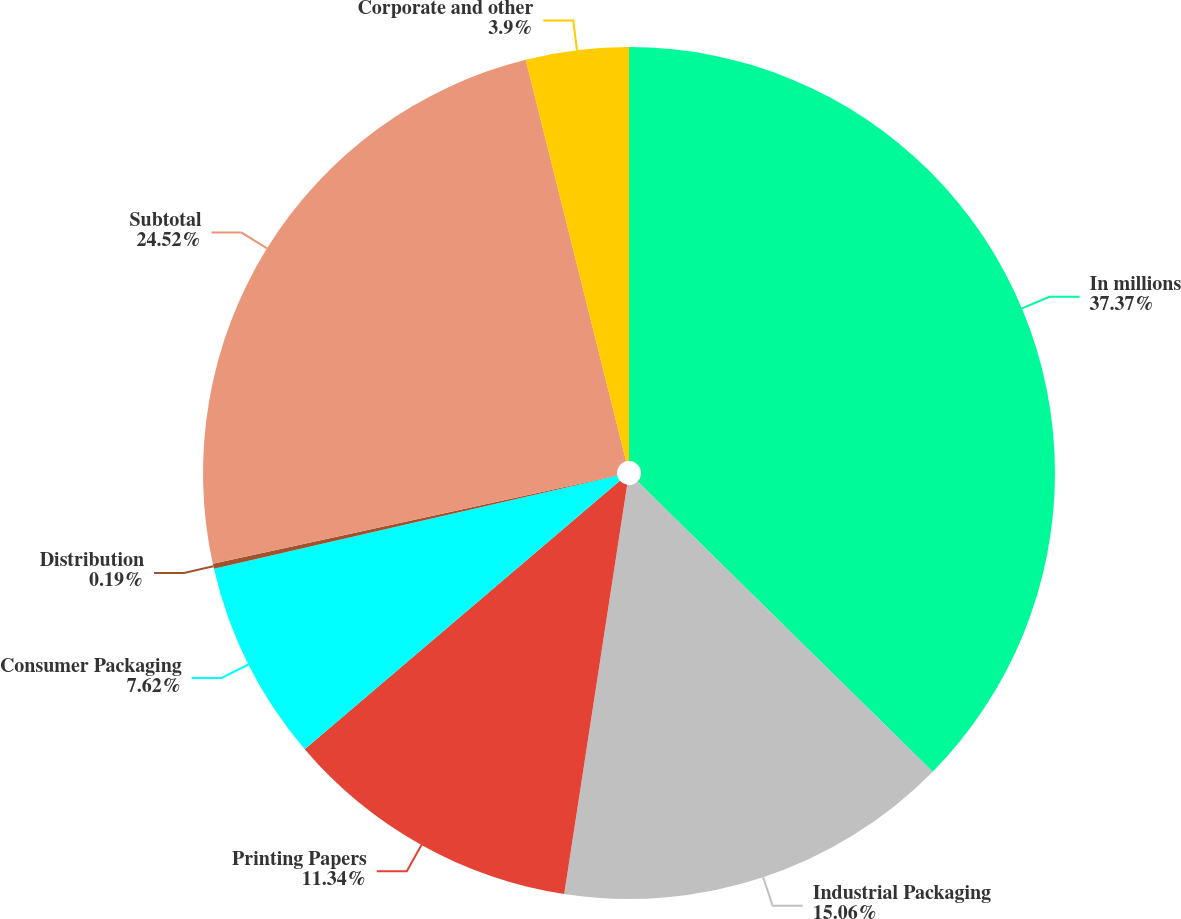<chart> <loc_0><loc_0><loc_500><loc_500><pie_chart><fcel>In millions<fcel>Industrial Packaging<fcel>Printing Papers<fcel>Consumer Packaging<fcel>Distribution<fcel>Subtotal<fcel>Corporate and other<nl><fcel>37.37%<fcel>15.06%<fcel>11.34%<fcel>7.62%<fcel>0.19%<fcel>24.52%<fcel>3.9%<nl></chart> 